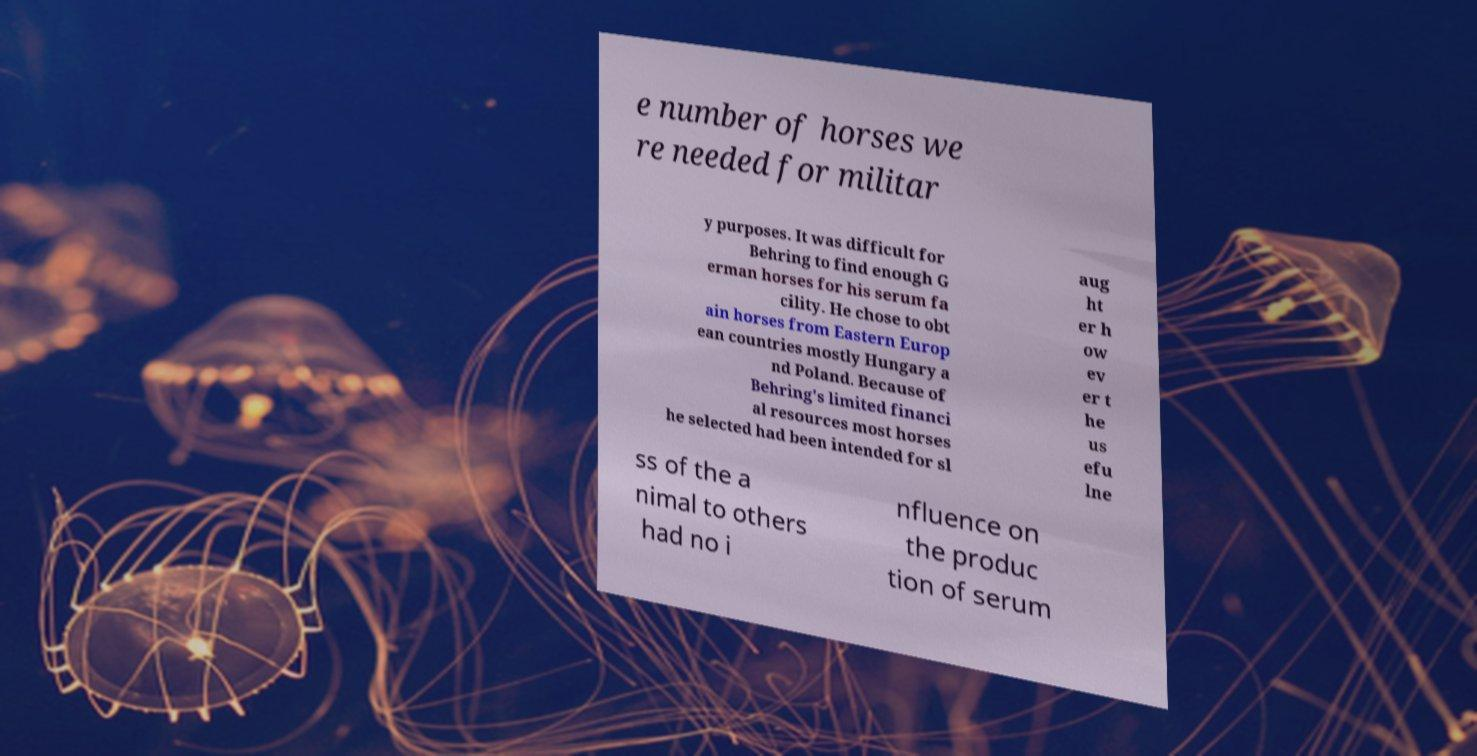What messages or text are displayed in this image? I need them in a readable, typed format. e number of horses we re needed for militar y purposes. It was difficult for Behring to find enough G erman horses for his serum fa cility. He chose to obt ain horses from Eastern Europ ean countries mostly Hungary a nd Poland. Because of Behring's limited financi al resources most horses he selected had been intended for sl aug ht er h ow ev er t he us efu lne ss of the a nimal to others had no i nfluence on the produc tion of serum 